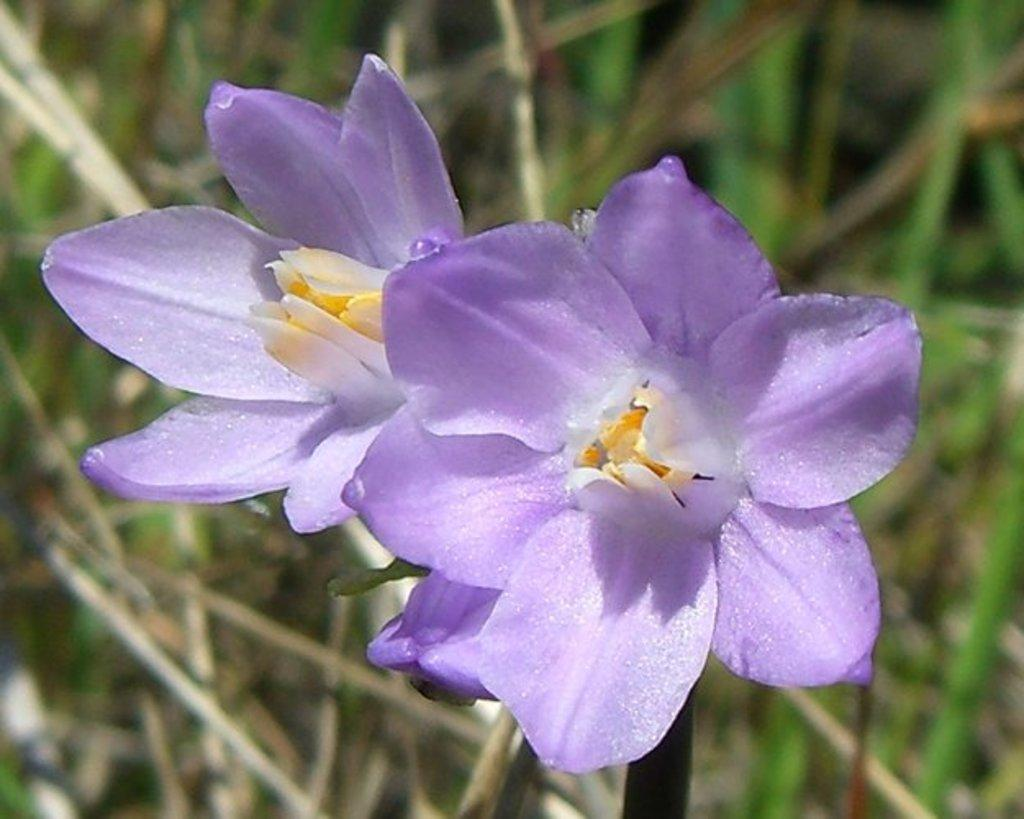What type of plants are in the image? There are flowers in the image. What color is the background of the image? The background of the image is blue. Where is the faucet located in the image? There is no faucet present in the image. What type of error can be seen in the image? There is no error present in the image; it is a clear image of flowers with a blue background. 